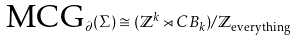Convert formula to latex. <formula><loc_0><loc_0><loc_500><loc_500>\text {MCG} _ { \partial } ( \Sigma ) \cong ( \mathbb { Z } ^ { k } \rtimes C B _ { k } ) / \mathbb { Z } _ { \text {everything} }</formula> 